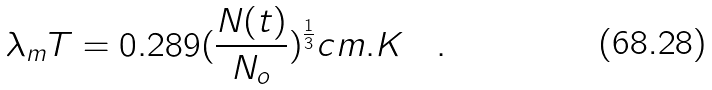Convert formula to latex. <formula><loc_0><loc_0><loc_500><loc_500>\lambda _ { m } T = 0 . 2 8 9 ( \frac { N ( t ) } { N _ { o } } ) ^ { \frac { 1 } { 3 } } c m . K \quad .</formula> 